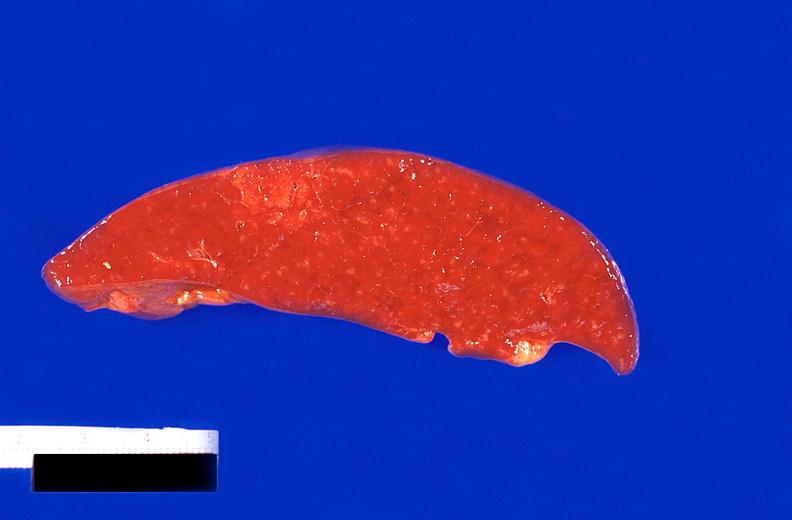s hematologic present?
Answer the question using a single word or phrase. Yes 